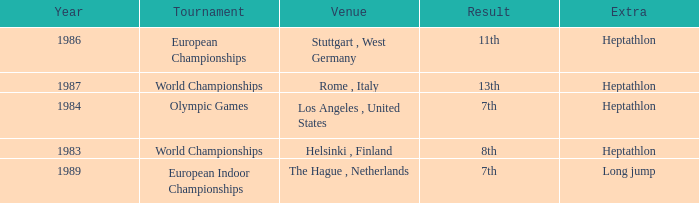How often are the Olympic games hosted? 1984.0. 